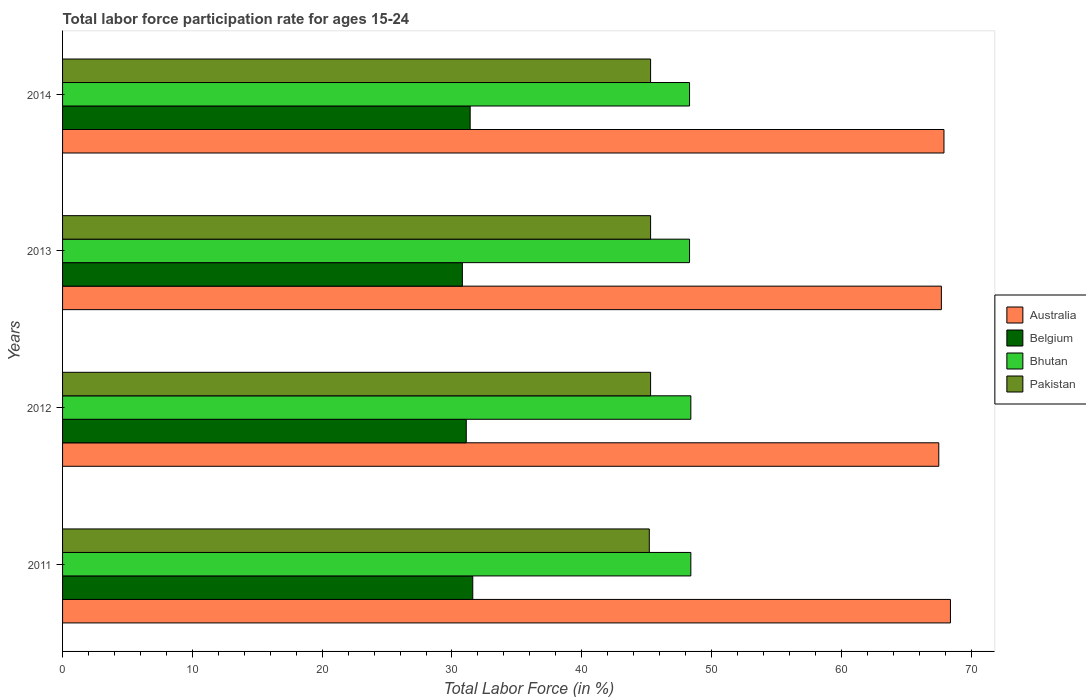How many different coloured bars are there?
Make the answer very short. 4. Are the number of bars per tick equal to the number of legend labels?
Provide a short and direct response. Yes. How many bars are there on the 3rd tick from the top?
Your answer should be compact. 4. How many bars are there on the 2nd tick from the bottom?
Provide a succinct answer. 4. What is the label of the 2nd group of bars from the top?
Ensure brevity in your answer.  2013. What is the labor force participation rate in Bhutan in 2014?
Offer a terse response. 48.3. Across all years, what is the maximum labor force participation rate in Belgium?
Make the answer very short. 31.6. Across all years, what is the minimum labor force participation rate in Australia?
Give a very brief answer. 67.5. In which year was the labor force participation rate in Pakistan minimum?
Make the answer very short. 2011. What is the total labor force participation rate in Pakistan in the graph?
Provide a succinct answer. 181.1. What is the difference between the labor force participation rate in Bhutan in 2011 and the labor force participation rate in Australia in 2013?
Provide a succinct answer. -19.3. What is the average labor force participation rate in Pakistan per year?
Offer a very short reply. 45.27. In the year 2014, what is the difference between the labor force participation rate in Belgium and labor force participation rate in Bhutan?
Give a very brief answer. -16.9. What is the ratio of the labor force participation rate in Belgium in 2013 to that in 2014?
Your answer should be compact. 0.98. Is the labor force participation rate in Bhutan in 2011 less than that in 2012?
Your answer should be compact. No. Is the difference between the labor force participation rate in Belgium in 2012 and 2014 greater than the difference between the labor force participation rate in Bhutan in 2012 and 2014?
Offer a terse response. No. What is the difference between the highest and the second highest labor force participation rate in Australia?
Provide a succinct answer. 0.5. What is the difference between the highest and the lowest labor force participation rate in Australia?
Keep it short and to the point. 0.9. Is the sum of the labor force participation rate in Belgium in 2011 and 2013 greater than the maximum labor force participation rate in Australia across all years?
Provide a succinct answer. No. What does the 4th bar from the top in 2012 represents?
Provide a succinct answer. Australia. Is it the case that in every year, the sum of the labor force participation rate in Bhutan and labor force participation rate in Australia is greater than the labor force participation rate in Pakistan?
Give a very brief answer. Yes. How many years are there in the graph?
Offer a terse response. 4. Are the values on the major ticks of X-axis written in scientific E-notation?
Make the answer very short. No. Does the graph contain grids?
Provide a short and direct response. No. Where does the legend appear in the graph?
Offer a terse response. Center right. What is the title of the graph?
Ensure brevity in your answer.  Total labor force participation rate for ages 15-24. Does "Sub-Saharan Africa (all income levels)" appear as one of the legend labels in the graph?
Your answer should be very brief. No. What is the label or title of the X-axis?
Ensure brevity in your answer.  Total Labor Force (in %). What is the label or title of the Y-axis?
Your answer should be compact. Years. What is the Total Labor Force (in %) in Australia in 2011?
Offer a very short reply. 68.4. What is the Total Labor Force (in %) of Belgium in 2011?
Make the answer very short. 31.6. What is the Total Labor Force (in %) of Bhutan in 2011?
Keep it short and to the point. 48.4. What is the Total Labor Force (in %) in Pakistan in 2011?
Offer a terse response. 45.2. What is the Total Labor Force (in %) in Australia in 2012?
Offer a terse response. 67.5. What is the Total Labor Force (in %) in Belgium in 2012?
Provide a short and direct response. 31.1. What is the Total Labor Force (in %) in Bhutan in 2012?
Offer a very short reply. 48.4. What is the Total Labor Force (in %) in Pakistan in 2012?
Offer a very short reply. 45.3. What is the Total Labor Force (in %) in Australia in 2013?
Your answer should be compact. 67.7. What is the Total Labor Force (in %) in Belgium in 2013?
Provide a short and direct response. 30.8. What is the Total Labor Force (in %) in Bhutan in 2013?
Keep it short and to the point. 48.3. What is the Total Labor Force (in %) in Pakistan in 2013?
Offer a very short reply. 45.3. What is the Total Labor Force (in %) in Australia in 2014?
Offer a very short reply. 67.9. What is the Total Labor Force (in %) in Belgium in 2014?
Your response must be concise. 31.4. What is the Total Labor Force (in %) of Bhutan in 2014?
Ensure brevity in your answer.  48.3. What is the Total Labor Force (in %) in Pakistan in 2014?
Keep it short and to the point. 45.3. Across all years, what is the maximum Total Labor Force (in %) in Australia?
Offer a terse response. 68.4. Across all years, what is the maximum Total Labor Force (in %) of Belgium?
Your response must be concise. 31.6. Across all years, what is the maximum Total Labor Force (in %) of Bhutan?
Ensure brevity in your answer.  48.4. Across all years, what is the maximum Total Labor Force (in %) of Pakistan?
Keep it short and to the point. 45.3. Across all years, what is the minimum Total Labor Force (in %) in Australia?
Your answer should be very brief. 67.5. Across all years, what is the minimum Total Labor Force (in %) of Belgium?
Offer a very short reply. 30.8. Across all years, what is the minimum Total Labor Force (in %) in Bhutan?
Your answer should be very brief. 48.3. Across all years, what is the minimum Total Labor Force (in %) of Pakistan?
Your answer should be compact. 45.2. What is the total Total Labor Force (in %) in Australia in the graph?
Provide a short and direct response. 271.5. What is the total Total Labor Force (in %) in Belgium in the graph?
Ensure brevity in your answer.  124.9. What is the total Total Labor Force (in %) of Bhutan in the graph?
Offer a terse response. 193.4. What is the total Total Labor Force (in %) in Pakistan in the graph?
Ensure brevity in your answer.  181.1. What is the difference between the Total Labor Force (in %) of Belgium in 2011 and that in 2012?
Your response must be concise. 0.5. What is the difference between the Total Labor Force (in %) of Pakistan in 2011 and that in 2012?
Offer a very short reply. -0.1. What is the difference between the Total Labor Force (in %) in Belgium in 2011 and that in 2013?
Your response must be concise. 0.8. What is the difference between the Total Labor Force (in %) of Australia in 2011 and that in 2014?
Offer a terse response. 0.5. What is the difference between the Total Labor Force (in %) of Bhutan in 2012 and that in 2013?
Provide a succinct answer. 0.1. What is the difference between the Total Labor Force (in %) of Pakistan in 2012 and that in 2013?
Offer a very short reply. 0. What is the difference between the Total Labor Force (in %) of Australia in 2012 and that in 2014?
Make the answer very short. -0.4. What is the difference between the Total Labor Force (in %) in Australia in 2013 and that in 2014?
Keep it short and to the point. -0.2. What is the difference between the Total Labor Force (in %) of Pakistan in 2013 and that in 2014?
Provide a short and direct response. 0. What is the difference between the Total Labor Force (in %) of Australia in 2011 and the Total Labor Force (in %) of Belgium in 2012?
Give a very brief answer. 37.3. What is the difference between the Total Labor Force (in %) in Australia in 2011 and the Total Labor Force (in %) in Bhutan in 2012?
Your answer should be very brief. 20. What is the difference between the Total Labor Force (in %) of Australia in 2011 and the Total Labor Force (in %) of Pakistan in 2012?
Offer a terse response. 23.1. What is the difference between the Total Labor Force (in %) of Belgium in 2011 and the Total Labor Force (in %) of Bhutan in 2012?
Your response must be concise. -16.8. What is the difference between the Total Labor Force (in %) of Belgium in 2011 and the Total Labor Force (in %) of Pakistan in 2012?
Your response must be concise. -13.7. What is the difference between the Total Labor Force (in %) of Australia in 2011 and the Total Labor Force (in %) of Belgium in 2013?
Offer a terse response. 37.6. What is the difference between the Total Labor Force (in %) in Australia in 2011 and the Total Labor Force (in %) in Bhutan in 2013?
Provide a short and direct response. 20.1. What is the difference between the Total Labor Force (in %) of Australia in 2011 and the Total Labor Force (in %) of Pakistan in 2013?
Your response must be concise. 23.1. What is the difference between the Total Labor Force (in %) in Belgium in 2011 and the Total Labor Force (in %) in Bhutan in 2013?
Provide a short and direct response. -16.7. What is the difference between the Total Labor Force (in %) of Belgium in 2011 and the Total Labor Force (in %) of Pakistan in 2013?
Offer a very short reply. -13.7. What is the difference between the Total Labor Force (in %) of Bhutan in 2011 and the Total Labor Force (in %) of Pakistan in 2013?
Your response must be concise. 3.1. What is the difference between the Total Labor Force (in %) of Australia in 2011 and the Total Labor Force (in %) of Bhutan in 2014?
Make the answer very short. 20.1. What is the difference between the Total Labor Force (in %) of Australia in 2011 and the Total Labor Force (in %) of Pakistan in 2014?
Provide a short and direct response. 23.1. What is the difference between the Total Labor Force (in %) in Belgium in 2011 and the Total Labor Force (in %) in Bhutan in 2014?
Your response must be concise. -16.7. What is the difference between the Total Labor Force (in %) in Belgium in 2011 and the Total Labor Force (in %) in Pakistan in 2014?
Give a very brief answer. -13.7. What is the difference between the Total Labor Force (in %) in Bhutan in 2011 and the Total Labor Force (in %) in Pakistan in 2014?
Offer a very short reply. 3.1. What is the difference between the Total Labor Force (in %) in Australia in 2012 and the Total Labor Force (in %) in Belgium in 2013?
Provide a short and direct response. 36.7. What is the difference between the Total Labor Force (in %) of Australia in 2012 and the Total Labor Force (in %) of Pakistan in 2013?
Provide a succinct answer. 22.2. What is the difference between the Total Labor Force (in %) of Belgium in 2012 and the Total Labor Force (in %) of Bhutan in 2013?
Provide a short and direct response. -17.2. What is the difference between the Total Labor Force (in %) in Belgium in 2012 and the Total Labor Force (in %) in Pakistan in 2013?
Keep it short and to the point. -14.2. What is the difference between the Total Labor Force (in %) in Bhutan in 2012 and the Total Labor Force (in %) in Pakistan in 2013?
Offer a very short reply. 3.1. What is the difference between the Total Labor Force (in %) of Australia in 2012 and the Total Labor Force (in %) of Belgium in 2014?
Your response must be concise. 36.1. What is the difference between the Total Labor Force (in %) in Australia in 2012 and the Total Labor Force (in %) in Pakistan in 2014?
Make the answer very short. 22.2. What is the difference between the Total Labor Force (in %) of Belgium in 2012 and the Total Labor Force (in %) of Bhutan in 2014?
Your response must be concise. -17.2. What is the difference between the Total Labor Force (in %) of Belgium in 2012 and the Total Labor Force (in %) of Pakistan in 2014?
Your answer should be compact. -14.2. What is the difference between the Total Labor Force (in %) of Bhutan in 2012 and the Total Labor Force (in %) of Pakistan in 2014?
Offer a terse response. 3.1. What is the difference between the Total Labor Force (in %) of Australia in 2013 and the Total Labor Force (in %) of Belgium in 2014?
Offer a very short reply. 36.3. What is the difference between the Total Labor Force (in %) in Australia in 2013 and the Total Labor Force (in %) in Pakistan in 2014?
Offer a terse response. 22.4. What is the difference between the Total Labor Force (in %) of Belgium in 2013 and the Total Labor Force (in %) of Bhutan in 2014?
Your answer should be compact. -17.5. What is the average Total Labor Force (in %) in Australia per year?
Your answer should be very brief. 67.88. What is the average Total Labor Force (in %) of Belgium per year?
Keep it short and to the point. 31.23. What is the average Total Labor Force (in %) in Bhutan per year?
Your response must be concise. 48.35. What is the average Total Labor Force (in %) of Pakistan per year?
Offer a very short reply. 45.27. In the year 2011, what is the difference between the Total Labor Force (in %) of Australia and Total Labor Force (in %) of Belgium?
Provide a short and direct response. 36.8. In the year 2011, what is the difference between the Total Labor Force (in %) in Australia and Total Labor Force (in %) in Bhutan?
Provide a succinct answer. 20. In the year 2011, what is the difference between the Total Labor Force (in %) of Australia and Total Labor Force (in %) of Pakistan?
Your response must be concise. 23.2. In the year 2011, what is the difference between the Total Labor Force (in %) of Belgium and Total Labor Force (in %) of Bhutan?
Provide a succinct answer. -16.8. In the year 2011, what is the difference between the Total Labor Force (in %) of Bhutan and Total Labor Force (in %) of Pakistan?
Offer a terse response. 3.2. In the year 2012, what is the difference between the Total Labor Force (in %) in Australia and Total Labor Force (in %) in Belgium?
Provide a short and direct response. 36.4. In the year 2012, what is the difference between the Total Labor Force (in %) in Belgium and Total Labor Force (in %) in Bhutan?
Your answer should be very brief. -17.3. In the year 2012, what is the difference between the Total Labor Force (in %) of Bhutan and Total Labor Force (in %) of Pakistan?
Provide a succinct answer. 3.1. In the year 2013, what is the difference between the Total Labor Force (in %) of Australia and Total Labor Force (in %) of Belgium?
Give a very brief answer. 36.9. In the year 2013, what is the difference between the Total Labor Force (in %) of Australia and Total Labor Force (in %) of Pakistan?
Make the answer very short. 22.4. In the year 2013, what is the difference between the Total Labor Force (in %) of Belgium and Total Labor Force (in %) of Bhutan?
Your answer should be compact. -17.5. In the year 2014, what is the difference between the Total Labor Force (in %) in Australia and Total Labor Force (in %) in Belgium?
Give a very brief answer. 36.5. In the year 2014, what is the difference between the Total Labor Force (in %) of Australia and Total Labor Force (in %) of Bhutan?
Offer a terse response. 19.6. In the year 2014, what is the difference between the Total Labor Force (in %) in Australia and Total Labor Force (in %) in Pakistan?
Provide a short and direct response. 22.6. In the year 2014, what is the difference between the Total Labor Force (in %) of Belgium and Total Labor Force (in %) of Bhutan?
Your answer should be very brief. -16.9. In the year 2014, what is the difference between the Total Labor Force (in %) of Belgium and Total Labor Force (in %) of Pakistan?
Your response must be concise. -13.9. In the year 2014, what is the difference between the Total Labor Force (in %) in Bhutan and Total Labor Force (in %) in Pakistan?
Your response must be concise. 3. What is the ratio of the Total Labor Force (in %) of Australia in 2011 to that in 2012?
Your answer should be very brief. 1.01. What is the ratio of the Total Labor Force (in %) of Belgium in 2011 to that in 2012?
Your answer should be compact. 1.02. What is the ratio of the Total Labor Force (in %) in Bhutan in 2011 to that in 2012?
Your answer should be very brief. 1. What is the ratio of the Total Labor Force (in %) of Pakistan in 2011 to that in 2012?
Make the answer very short. 1. What is the ratio of the Total Labor Force (in %) of Australia in 2011 to that in 2013?
Your answer should be compact. 1.01. What is the ratio of the Total Labor Force (in %) of Bhutan in 2011 to that in 2013?
Your response must be concise. 1. What is the ratio of the Total Labor Force (in %) of Australia in 2011 to that in 2014?
Ensure brevity in your answer.  1.01. What is the ratio of the Total Labor Force (in %) in Belgium in 2011 to that in 2014?
Provide a short and direct response. 1.01. What is the ratio of the Total Labor Force (in %) in Bhutan in 2011 to that in 2014?
Make the answer very short. 1. What is the ratio of the Total Labor Force (in %) in Australia in 2012 to that in 2013?
Offer a terse response. 1. What is the ratio of the Total Labor Force (in %) of Belgium in 2012 to that in 2013?
Provide a short and direct response. 1.01. What is the ratio of the Total Labor Force (in %) of Pakistan in 2012 to that in 2013?
Offer a terse response. 1. What is the ratio of the Total Labor Force (in %) in Australia in 2012 to that in 2014?
Offer a very short reply. 0.99. What is the ratio of the Total Labor Force (in %) in Bhutan in 2012 to that in 2014?
Provide a short and direct response. 1. What is the ratio of the Total Labor Force (in %) in Belgium in 2013 to that in 2014?
Your answer should be compact. 0.98. What is the ratio of the Total Labor Force (in %) of Bhutan in 2013 to that in 2014?
Provide a succinct answer. 1. What is the ratio of the Total Labor Force (in %) in Pakistan in 2013 to that in 2014?
Provide a succinct answer. 1. What is the difference between the highest and the second highest Total Labor Force (in %) of Belgium?
Your answer should be very brief. 0.2. What is the difference between the highest and the second highest Total Labor Force (in %) in Pakistan?
Your response must be concise. 0. What is the difference between the highest and the lowest Total Labor Force (in %) of Australia?
Offer a terse response. 0.9. 